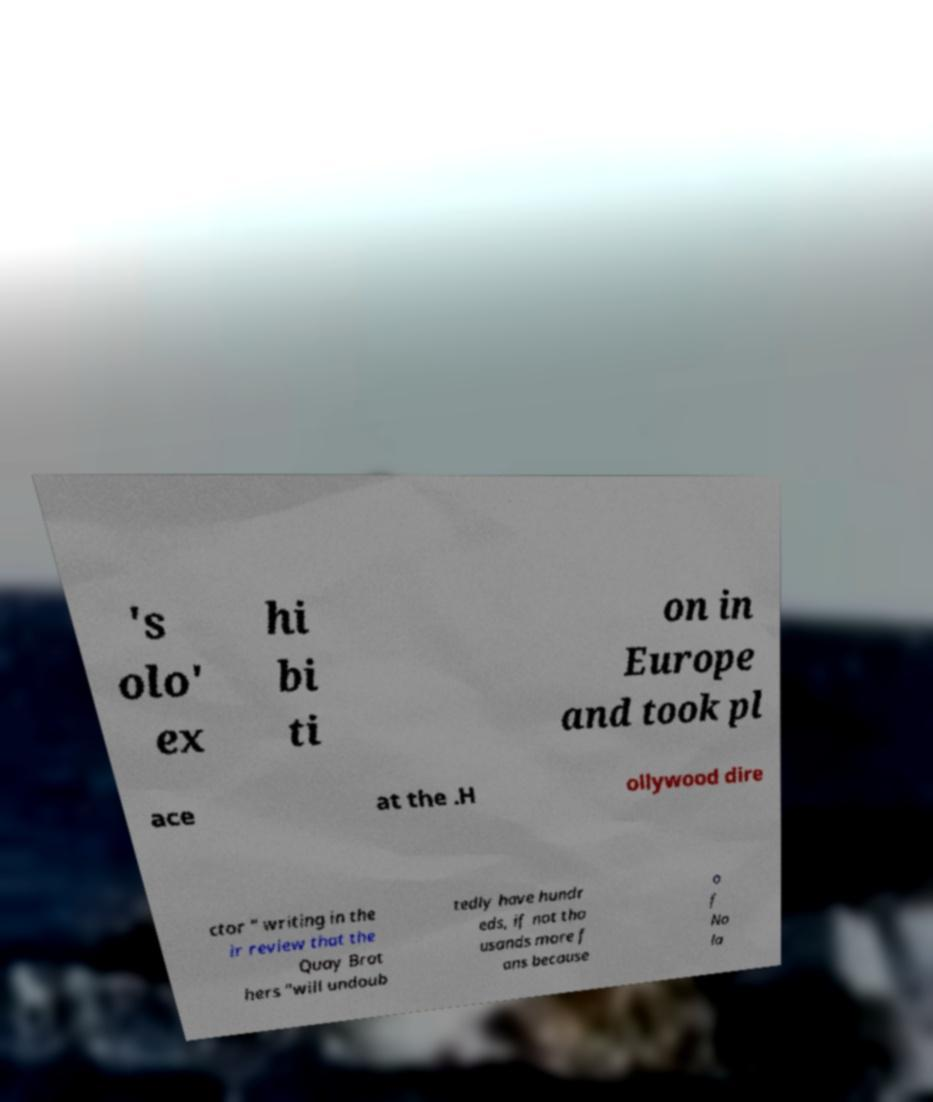Please read and relay the text visible in this image. What does it say? 's olo' ex hi bi ti on in Europe and took pl ace at the .H ollywood dire ctor " writing in the ir review that the Quay Brot hers "will undoub tedly have hundr eds, if not tho usands more f ans because o f No la 